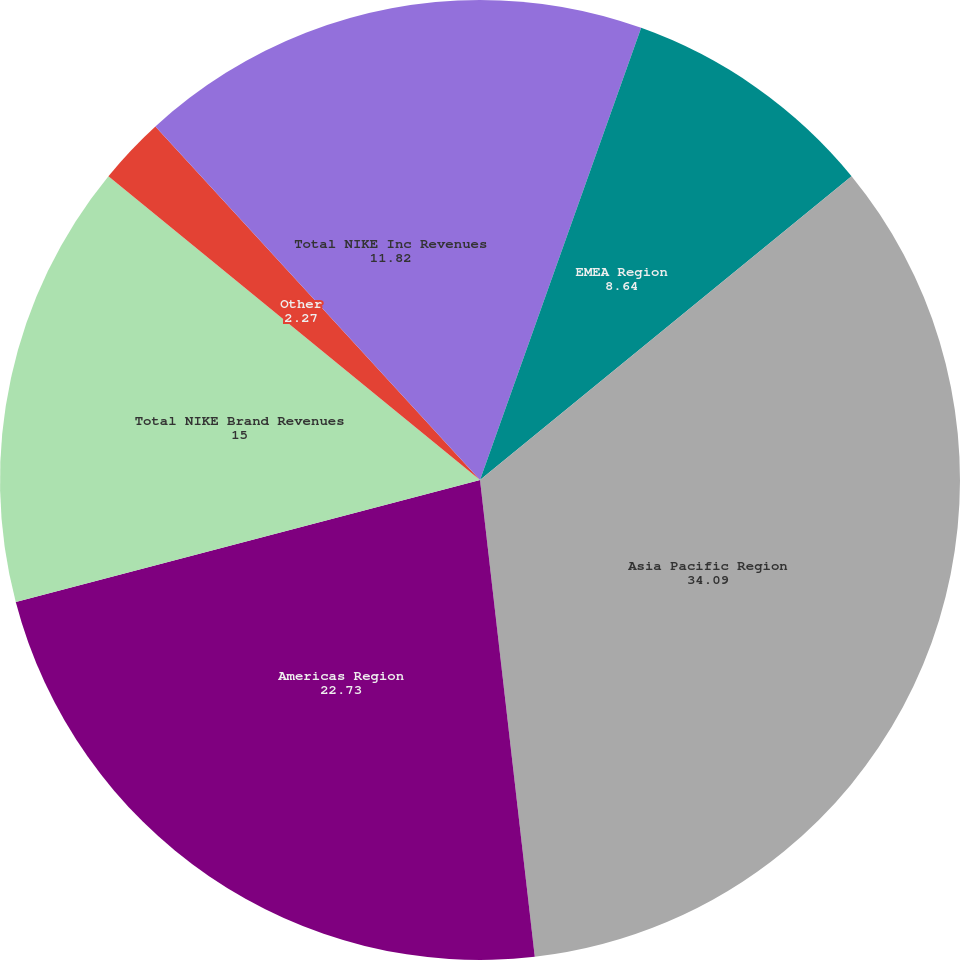Convert chart. <chart><loc_0><loc_0><loc_500><loc_500><pie_chart><fcel>US Region<fcel>EMEA Region<fcel>Asia Pacific Region<fcel>Americas Region<fcel>Total NIKE Brand Revenues<fcel>Other<fcel>Total NIKE Inc Revenues<nl><fcel>5.45%<fcel>8.64%<fcel>34.09%<fcel>22.73%<fcel>15.0%<fcel>2.27%<fcel>11.82%<nl></chart> 